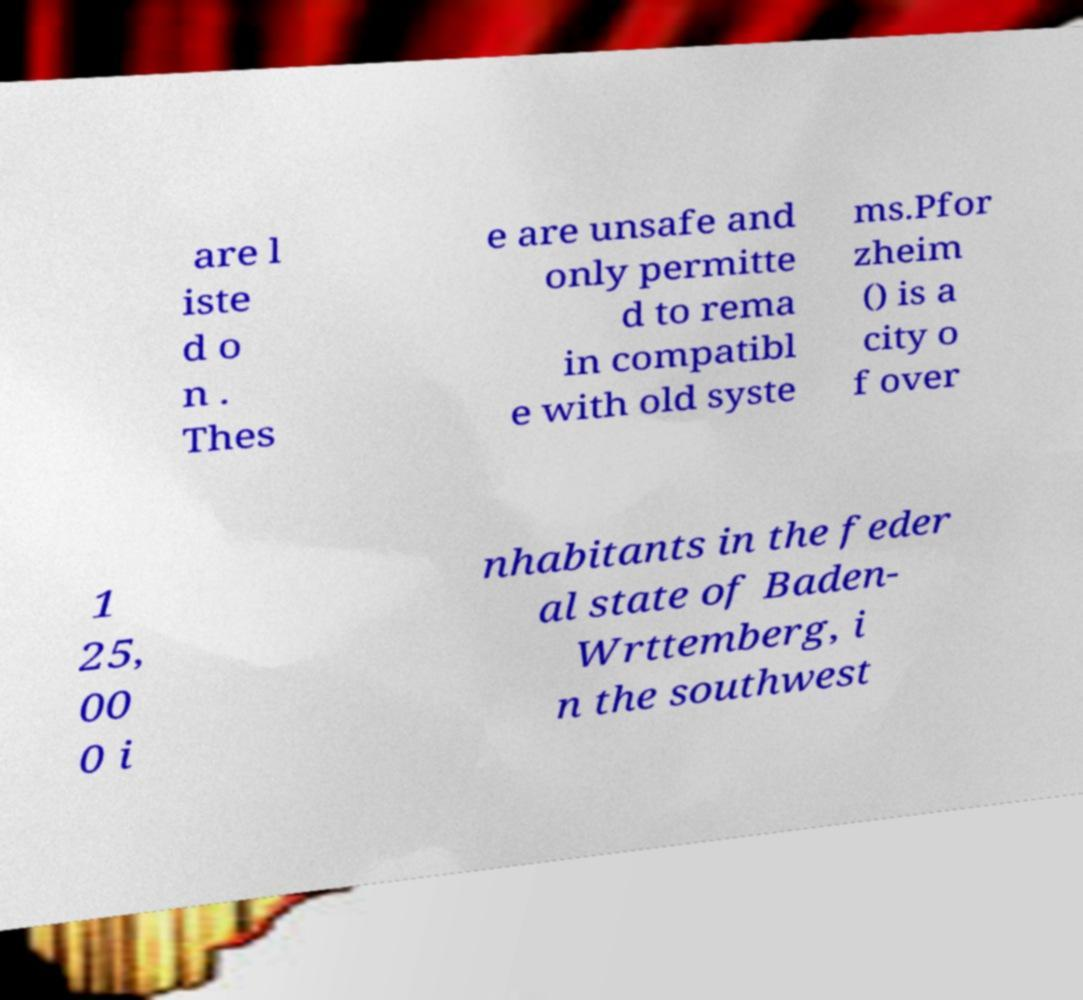There's text embedded in this image that I need extracted. Can you transcribe it verbatim? are l iste d o n . Thes e are unsafe and only permitte d to rema in compatibl e with old syste ms.Pfor zheim () is a city o f over 1 25, 00 0 i nhabitants in the feder al state of Baden- Wrttemberg, i n the southwest 